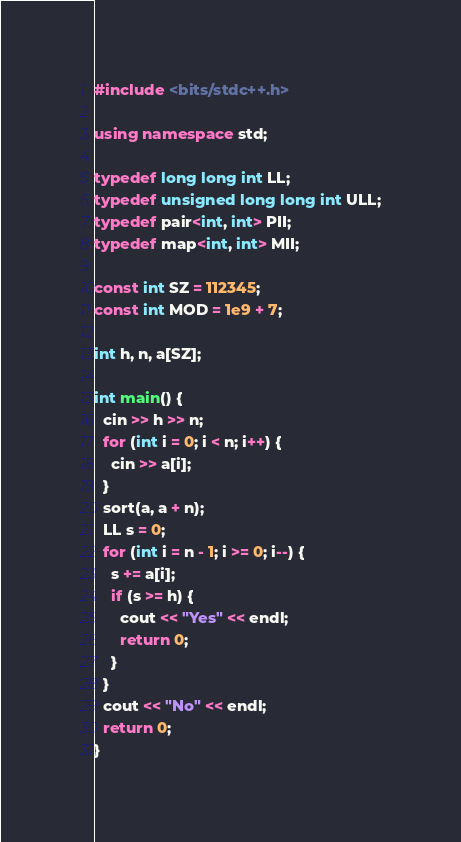<code> <loc_0><loc_0><loc_500><loc_500><_C++_>#include <bits/stdc++.h>

using namespace std;

typedef long long int LL;
typedef unsigned long long int ULL;
typedef pair<int, int> PII;
typedef map<int, int> MII;

const int SZ = 112345;
const int MOD = 1e9 + 7;

int h, n, a[SZ];

int main() {
  cin >> h >> n;
  for (int i = 0; i < n; i++) {
    cin >> a[i];
  }
  sort(a, a + n);
  LL s = 0;
  for (int i = n - 1; i >= 0; i--) {
    s += a[i];
    if (s >= h) {
      cout << "Yes" << endl;
      return 0;
    }
  }
  cout << "No" << endl;
  return 0;
}
</code> 